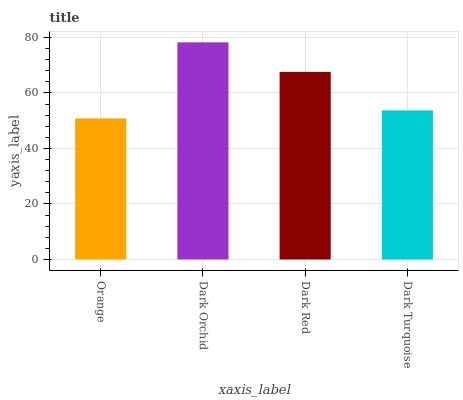Is Orange the minimum?
Answer yes or no. Yes. Is Dark Orchid the maximum?
Answer yes or no. Yes. Is Dark Red the minimum?
Answer yes or no. No. Is Dark Red the maximum?
Answer yes or no. No. Is Dark Orchid greater than Dark Red?
Answer yes or no. Yes. Is Dark Red less than Dark Orchid?
Answer yes or no. Yes. Is Dark Red greater than Dark Orchid?
Answer yes or no. No. Is Dark Orchid less than Dark Red?
Answer yes or no. No. Is Dark Red the high median?
Answer yes or no. Yes. Is Dark Turquoise the low median?
Answer yes or no. Yes. Is Dark Turquoise the high median?
Answer yes or no. No. Is Orange the low median?
Answer yes or no. No. 